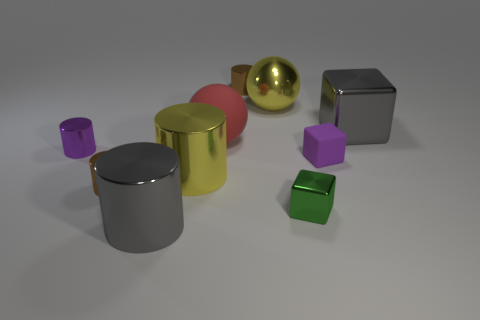How many metallic objects are either big yellow things or large cyan cylinders?
Your answer should be compact. 2. Are there any big yellow shiny balls?
Provide a succinct answer. Yes. Is the shape of the red thing the same as the small green metal object?
Offer a terse response. No. There is a brown metallic thing to the right of the gray metal thing that is in front of the gray metal cube; how many gray metal things are in front of it?
Give a very brief answer. 2. What is the material of the large object that is right of the large rubber ball and left of the gray shiny cube?
Keep it short and to the point. Metal. The big thing that is behind the tiny metal cube and on the left side of the large red matte sphere is what color?
Ensure brevity in your answer.  Yellow. Is there anything else of the same color as the rubber block?
Give a very brief answer. Yes. There is a brown metallic thing that is left of the big gray metallic object left of the large gray thing right of the tiny purple rubber block; what shape is it?
Ensure brevity in your answer.  Cylinder. The large object that is the same shape as the tiny green metallic object is what color?
Ensure brevity in your answer.  Gray. What is the color of the metal cube that is behind the matte object that is on the right side of the matte sphere?
Offer a very short reply. Gray. 